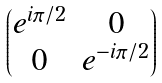<formula> <loc_0><loc_0><loc_500><loc_500>\begin{pmatrix} e ^ { i \pi / 2 } & 0 \\ 0 & e ^ { - i \pi / 2 } \end{pmatrix}</formula> 